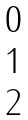<formula> <loc_0><loc_0><loc_500><loc_500>\begin{matrix} 0 \\ 1 \\ 2 \end{matrix}</formula> 